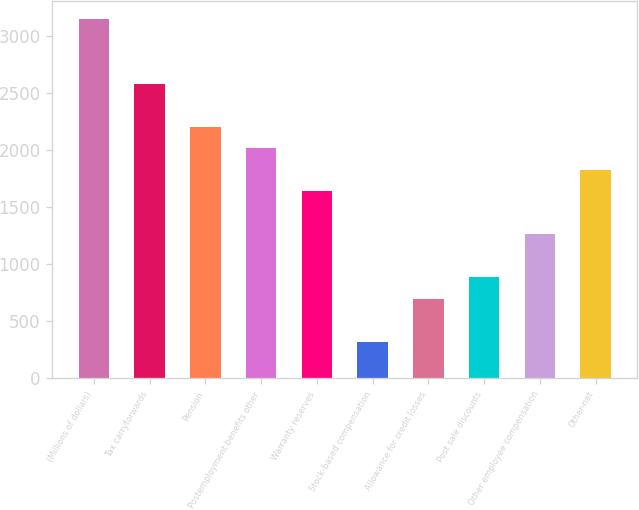<chart> <loc_0><loc_0><loc_500><loc_500><bar_chart><fcel>(Millions of dollars)<fcel>Tax carryforwards<fcel>Pension<fcel>Postemployment benefits other<fcel>Warranty reserves<fcel>Stock-based compensation<fcel>Allowance for credit losses<fcel>Post sale discounts<fcel>Other employee compensation<fcel>Other-net<nl><fcel>3147.4<fcel>2582.2<fcel>2205.4<fcel>2017<fcel>1640.2<fcel>321.4<fcel>698.2<fcel>886.6<fcel>1263.4<fcel>1828.6<nl></chart> 